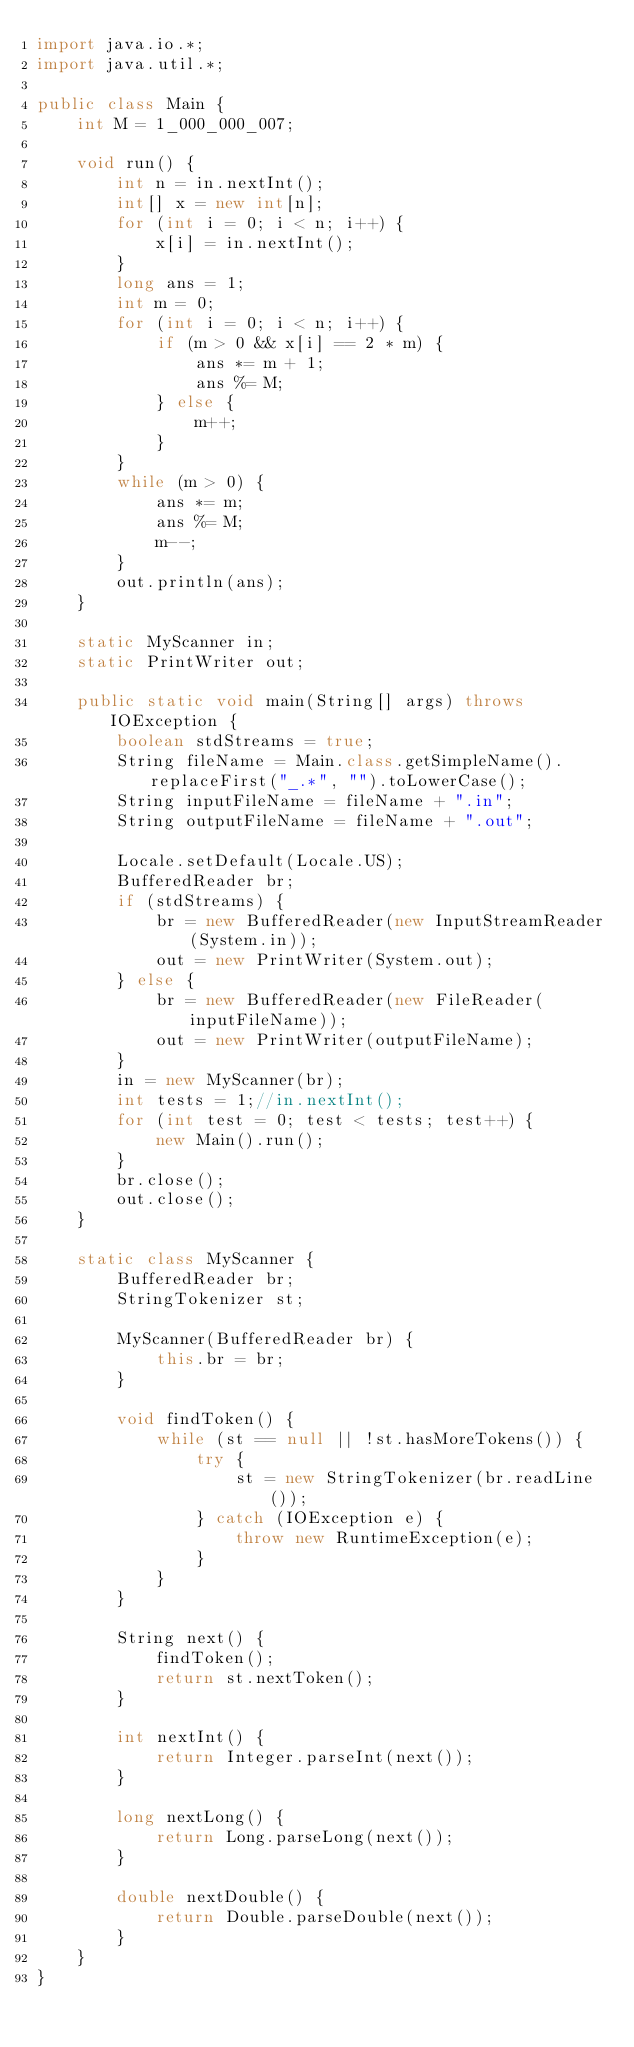<code> <loc_0><loc_0><loc_500><loc_500><_Java_>import java.io.*;
import java.util.*;

public class Main {
	int M = 1_000_000_007;
	
	void run() {
		int n = in.nextInt();
		int[] x = new int[n];
		for (int i = 0; i < n; i++) {
			x[i] = in.nextInt();
		}
		long ans = 1;
		int m = 0;
		for (int i = 0; i < n; i++) {
			if (m > 0 && x[i] == 2 * m) {
				ans *= m + 1;
				ans %= M;
			} else {
				m++;
			}
		}
		while (m > 0) {
			ans *= m;
			ans %= M;
			m--;
		}
		out.println(ans);
	}

	static MyScanner in;
	static PrintWriter out;

	public static void main(String[] args) throws IOException {
		boolean stdStreams = true;
		String fileName = Main.class.getSimpleName().replaceFirst("_.*", "").toLowerCase();
		String inputFileName = fileName + ".in";
		String outputFileName = fileName + ".out";
		
		Locale.setDefault(Locale.US);
		BufferedReader br;
		if (stdStreams) {
			br = new BufferedReader(new InputStreamReader(System.in));
			out = new PrintWriter(System.out);
		} else {
			br = new BufferedReader(new FileReader(inputFileName));
			out = new PrintWriter(outputFileName);
		}
		in = new MyScanner(br);
		int tests = 1;//in.nextInt();
		for (int test = 0; test < tests; test++) {
			new Main().run();
		}
		br.close();
		out.close();
	}
	
	static class MyScanner {
		BufferedReader br;
		StringTokenizer st;

		MyScanner(BufferedReader br) {
			this.br = br;
		}
		
		void findToken() {
			while (st == null || !st.hasMoreTokens()) {
				try {
					st = new StringTokenizer(br.readLine());
				} catch (IOException e) {
					throw new RuntimeException(e);
				}
			}
		}
		
		String next() {
			findToken();
			return st.nextToken();
		}
		
		int nextInt() {
			return Integer.parseInt(next());
		}
		
		long nextLong() {
			return Long.parseLong(next());
		}
		
		double nextDouble() {
			return Double.parseDouble(next());
		}
	}
}
</code> 